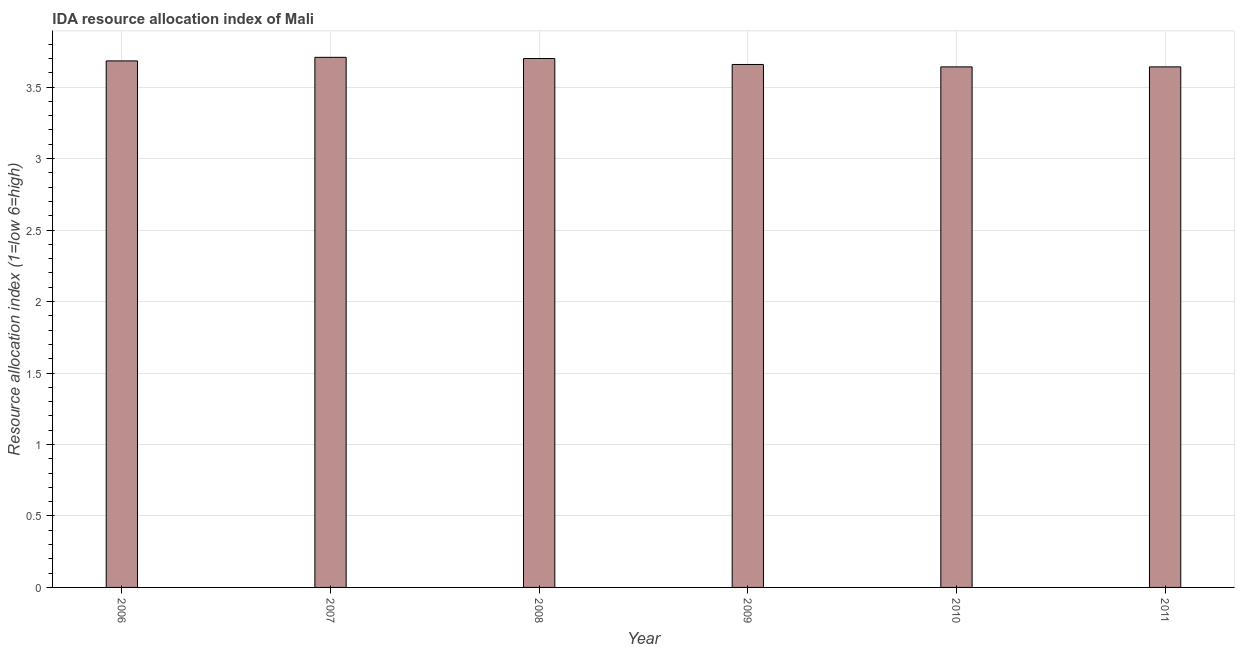Does the graph contain any zero values?
Provide a succinct answer. No. Does the graph contain grids?
Provide a succinct answer. Yes. What is the title of the graph?
Your answer should be compact. IDA resource allocation index of Mali. What is the label or title of the X-axis?
Your response must be concise. Year. What is the label or title of the Y-axis?
Keep it short and to the point. Resource allocation index (1=low 6=high). What is the ida resource allocation index in 2007?
Give a very brief answer. 3.71. Across all years, what is the maximum ida resource allocation index?
Give a very brief answer. 3.71. Across all years, what is the minimum ida resource allocation index?
Your response must be concise. 3.64. In which year was the ida resource allocation index minimum?
Offer a terse response. 2010. What is the sum of the ida resource allocation index?
Give a very brief answer. 22.03. What is the difference between the ida resource allocation index in 2006 and 2009?
Offer a terse response. 0.03. What is the average ida resource allocation index per year?
Ensure brevity in your answer.  3.67. What is the median ida resource allocation index?
Your response must be concise. 3.67. Do a majority of the years between 2011 and 2010 (inclusive) have ida resource allocation index greater than 3 ?
Provide a succinct answer. No. What is the ratio of the ida resource allocation index in 2009 to that in 2011?
Your answer should be compact. 1. What is the difference between the highest and the second highest ida resource allocation index?
Ensure brevity in your answer.  0.01. What is the difference between the highest and the lowest ida resource allocation index?
Your answer should be very brief. 0.07. How many bars are there?
Your response must be concise. 6. Are all the bars in the graph horizontal?
Make the answer very short. No. How many years are there in the graph?
Provide a succinct answer. 6. What is the Resource allocation index (1=low 6=high) of 2006?
Your answer should be very brief. 3.68. What is the Resource allocation index (1=low 6=high) of 2007?
Offer a very short reply. 3.71. What is the Resource allocation index (1=low 6=high) of 2008?
Offer a very short reply. 3.7. What is the Resource allocation index (1=low 6=high) in 2009?
Offer a very short reply. 3.66. What is the Resource allocation index (1=low 6=high) of 2010?
Ensure brevity in your answer.  3.64. What is the Resource allocation index (1=low 6=high) in 2011?
Offer a terse response. 3.64. What is the difference between the Resource allocation index (1=low 6=high) in 2006 and 2007?
Ensure brevity in your answer.  -0.03. What is the difference between the Resource allocation index (1=low 6=high) in 2006 and 2008?
Your answer should be compact. -0.02. What is the difference between the Resource allocation index (1=low 6=high) in 2006 and 2009?
Your answer should be very brief. 0.03. What is the difference between the Resource allocation index (1=low 6=high) in 2006 and 2010?
Your response must be concise. 0.04. What is the difference between the Resource allocation index (1=low 6=high) in 2006 and 2011?
Offer a very short reply. 0.04. What is the difference between the Resource allocation index (1=low 6=high) in 2007 and 2008?
Offer a terse response. 0.01. What is the difference between the Resource allocation index (1=low 6=high) in 2007 and 2009?
Keep it short and to the point. 0.05. What is the difference between the Resource allocation index (1=low 6=high) in 2007 and 2010?
Your response must be concise. 0.07. What is the difference between the Resource allocation index (1=low 6=high) in 2007 and 2011?
Give a very brief answer. 0.07. What is the difference between the Resource allocation index (1=low 6=high) in 2008 and 2009?
Offer a very short reply. 0.04. What is the difference between the Resource allocation index (1=low 6=high) in 2008 and 2010?
Give a very brief answer. 0.06. What is the difference between the Resource allocation index (1=low 6=high) in 2008 and 2011?
Offer a very short reply. 0.06. What is the difference between the Resource allocation index (1=low 6=high) in 2009 and 2010?
Provide a succinct answer. 0.02. What is the difference between the Resource allocation index (1=low 6=high) in 2009 and 2011?
Your answer should be very brief. 0.02. What is the difference between the Resource allocation index (1=low 6=high) in 2010 and 2011?
Make the answer very short. 0. What is the ratio of the Resource allocation index (1=low 6=high) in 2006 to that in 2010?
Make the answer very short. 1.01. What is the ratio of the Resource allocation index (1=low 6=high) in 2007 to that in 2008?
Keep it short and to the point. 1. What is the ratio of the Resource allocation index (1=low 6=high) in 2007 to that in 2009?
Ensure brevity in your answer.  1.01. What is the ratio of the Resource allocation index (1=low 6=high) in 2007 to that in 2010?
Your answer should be very brief. 1.02. What is the ratio of the Resource allocation index (1=low 6=high) in 2008 to that in 2009?
Your answer should be very brief. 1.01. What is the ratio of the Resource allocation index (1=low 6=high) in 2008 to that in 2010?
Your answer should be very brief. 1.02. What is the ratio of the Resource allocation index (1=low 6=high) in 2009 to that in 2010?
Offer a terse response. 1. 